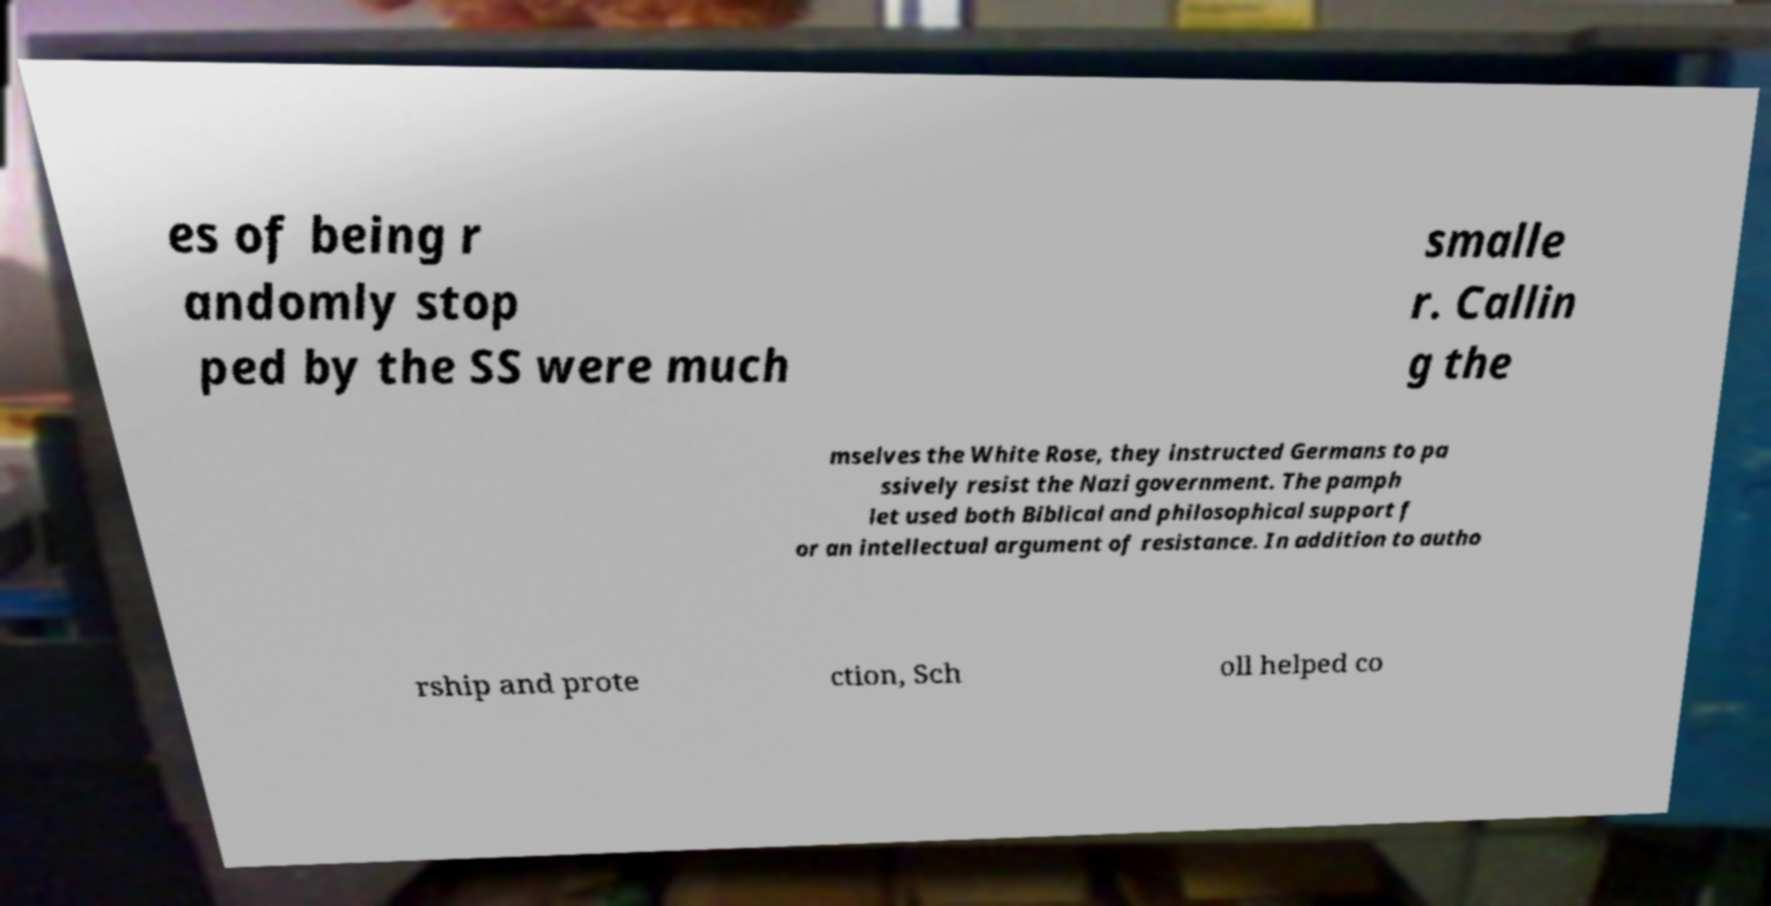For documentation purposes, I need the text within this image transcribed. Could you provide that? es of being r andomly stop ped by the SS were much smalle r. Callin g the mselves the White Rose, they instructed Germans to pa ssively resist the Nazi government. The pamph let used both Biblical and philosophical support f or an intellectual argument of resistance. In addition to autho rship and prote ction, Sch oll helped co 